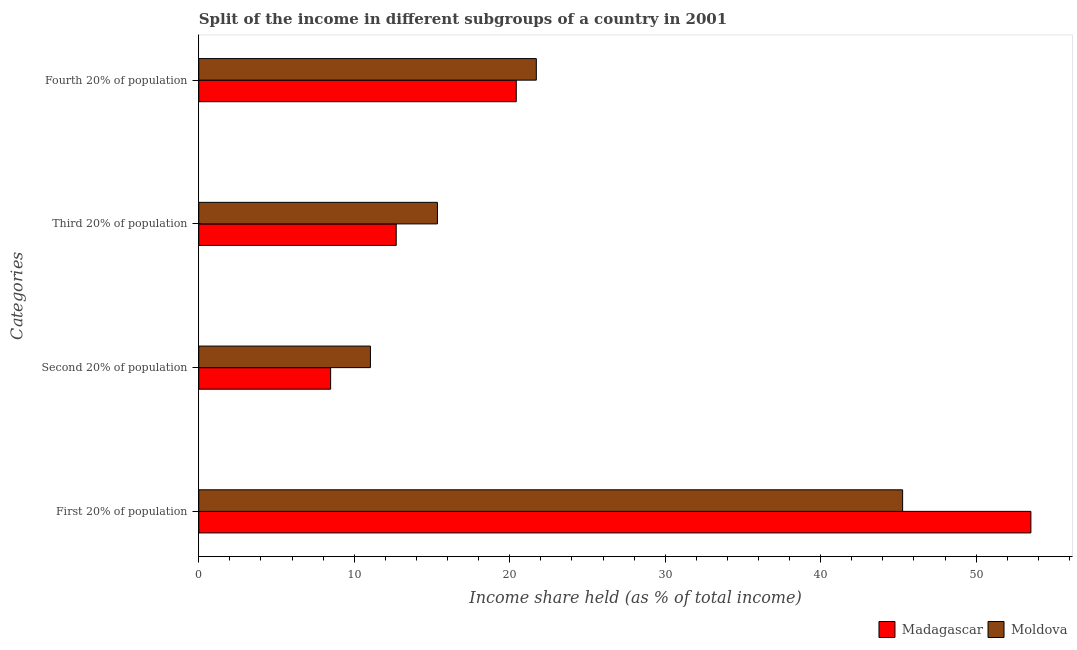How many different coloured bars are there?
Make the answer very short. 2. How many groups of bars are there?
Keep it short and to the point. 4. Are the number of bars per tick equal to the number of legend labels?
Offer a very short reply. Yes. What is the label of the 1st group of bars from the top?
Provide a short and direct response. Fourth 20% of population. What is the share of the income held by second 20% of the population in Moldova?
Make the answer very short. 11.04. Across all countries, what is the maximum share of the income held by first 20% of the population?
Give a very brief answer. 53.52. Across all countries, what is the minimum share of the income held by fourth 20% of the population?
Ensure brevity in your answer.  20.42. In which country was the share of the income held by first 20% of the population maximum?
Make the answer very short. Madagascar. In which country was the share of the income held by first 20% of the population minimum?
Your answer should be very brief. Moldova. What is the total share of the income held by second 20% of the population in the graph?
Offer a terse response. 19.52. What is the difference between the share of the income held by first 20% of the population in Moldova and that in Madagascar?
Provide a succinct answer. -8.25. What is the difference between the share of the income held by first 20% of the population in Moldova and the share of the income held by fourth 20% of the population in Madagascar?
Provide a succinct answer. 24.85. What is the average share of the income held by second 20% of the population per country?
Provide a short and direct response. 9.76. What is the difference between the share of the income held by first 20% of the population and share of the income held by fourth 20% of the population in Madagascar?
Provide a short and direct response. 33.1. In how many countries, is the share of the income held by third 20% of the population greater than 16 %?
Make the answer very short. 0. What is the ratio of the share of the income held by first 20% of the population in Madagascar to that in Moldova?
Keep it short and to the point. 1.18. Is the difference between the share of the income held by fourth 20% of the population in Moldova and Madagascar greater than the difference between the share of the income held by second 20% of the population in Moldova and Madagascar?
Give a very brief answer. No. What is the difference between the highest and the second highest share of the income held by fourth 20% of the population?
Keep it short and to the point. 1.29. What is the difference between the highest and the lowest share of the income held by first 20% of the population?
Make the answer very short. 8.25. In how many countries, is the share of the income held by fourth 20% of the population greater than the average share of the income held by fourth 20% of the population taken over all countries?
Give a very brief answer. 1. Is the sum of the share of the income held by first 20% of the population in Moldova and Madagascar greater than the maximum share of the income held by third 20% of the population across all countries?
Make the answer very short. Yes. What does the 1st bar from the top in First 20% of population represents?
Your answer should be very brief. Moldova. What does the 1st bar from the bottom in Fourth 20% of population represents?
Give a very brief answer. Madagascar. Is it the case that in every country, the sum of the share of the income held by first 20% of the population and share of the income held by second 20% of the population is greater than the share of the income held by third 20% of the population?
Your answer should be very brief. Yes. How many bars are there?
Your answer should be very brief. 8. Are all the bars in the graph horizontal?
Make the answer very short. Yes. How many countries are there in the graph?
Your answer should be compact. 2. Are the values on the major ticks of X-axis written in scientific E-notation?
Make the answer very short. No. Where does the legend appear in the graph?
Your response must be concise. Bottom right. How are the legend labels stacked?
Offer a terse response. Horizontal. What is the title of the graph?
Your response must be concise. Split of the income in different subgroups of a country in 2001. What is the label or title of the X-axis?
Your answer should be compact. Income share held (as % of total income). What is the label or title of the Y-axis?
Ensure brevity in your answer.  Categories. What is the Income share held (as % of total income) of Madagascar in First 20% of population?
Provide a short and direct response. 53.52. What is the Income share held (as % of total income) in Moldova in First 20% of population?
Keep it short and to the point. 45.27. What is the Income share held (as % of total income) in Madagascar in Second 20% of population?
Offer a very short reply. 8.48. What is the Income share held (as % of total income) in Moldova in Second 20% of population?
Offer a terse response. 11.04. What is the Income share held (as % of total income) of Moldova in Third 20% of population?
Your answer should be compact. 15.35. What is the Income share held (as % of total income) in Madagascar in Fourth 20% of population?
Your answer should be compact. 20.42. What is the Income share held (as % of total income) in Moldova in Fourth 20% of population?
Your answer should be very brief. 21.71. Across all Categories, what is the maximum Income share held (as % of total income) of Madagascar?
Keep it short and to the point. 53.52. Across all Categories, what is the maximum Income share held (as % of total income) of Moldova?
Your response must be concise. 45.27. Across all Categories, what is the minimum Income share held (as % of total income) in Madagascar?
Make the answer very short. 8.48. Across all Categories, what is the minimum Income share held (as % of total income) of Moldova?
Your answer should be compact. 11.04. What is the total Income share held (as % of total income) of Madagascar in the graph?
Your answer should be very brief. 95.12. What is the total Income share held (as % of total income) in Moldova in the graph?
Your response must be concise. 93.37. What is the difference between the Income share held (as % of total income) of Madagascar in First 20% of population and that in Second 20% of population?
Provide a succinct answer. 45.04. What is the difference between the Income share held (as % of total income) of Moldova in First 20% of population and that in Second 20% of population?
Ensure brevity in your answer.  34.23. What is the difference between the Income share held (as % of total income) in Madagascar in First 20% of population and that in Third 20% of population?
Your answer should be compact. 40.82. What is the difference between the Income share held (as % of total income) in Moldova in First 20% of population and that in Third 20% of population?
Make the answer very short. 29.92. What is the difference between the Income share held (as % of total income) in Madagascar in First 20% of population and that in Fourth 20% of population?
Provide a succinct answer. 33.1. What is the difference between the Income share held (as % of total income) in Moldova in First 20% of population and that in Fourth 20% of population?
Make the answer very short. 23.56. What is the difference between the Income share held (as % of total income) in Madagascar in Second 20% of population and that in Third 20% of population?
Your answer should be very brief. -4.22. What is the difference between the Income share held (as % of total income) in Moldova in Second 20% of population and that in Third 20% of population?
Offer a terse response. -4.31. What is the difference between the Income share held (as % of total income) in Madagascar in Second 20% of population and that in Fourth 20% of population?
Make the answer very short. -11.94. What is the difference between the Income share held (as % of total income) in Moldova in Second 20% of population and that in Fourth 20% of population?
Offer a very short reply. -10.67. What is the difference between the Income share held (as % of total income) in Madagascar in Third 20% of population and that in Fourth 20% of population?
Offer a terse response. -7.72. What is the difference between the Income share held (as % of total income) in Moldova in Third 20% of population and that in Fourth 20% of population?
Make the answer very short. -6.36. What is the difference between the Income share held (as % of total income) in Madagascar in First 20% of population and the Income share held (as % of total income) in Moldova in Second 20% of population?
Offer a terse response. 42.48. What is the difference between the Income share held (as % of total income) in Madagascar in First 20% of population and the Income share held (as % of total income) in Moldova in Third 20% of population?
Your answer should be very brief. 38.17. What is the difference between the Income share held (as % of total income) in Madagascar in First 20% of population and the Income share held (as % of total income) in Moldova in Fourth 20% of population?
Ensure brevity in your answer.  31.81. What is the difference between the Income share held (as % of total income) of Madagascar in Second 20% of population and the Income share held (as % of total income) of Moldova in Third 20% of population?
Give a very brief answer. -6.87. What is the difference between the Income share held (as % of total income) of Madagascar in Second 20% of population and the Income share held (as % of total income) of Moldova in Fourth 20% of population?
Give a very brief answer. -13.23. What is the difference between the Income share held (as % of total income) in Madagascar in Third 20% of population and the Income share held (as % of total income) in Moldova in Fourth 20% of population?
Offer a terse response. -9.01. What is the average Income share held (as % of total income) in Madagascar per Categories?
Your answer should be very brief. 23.78. What is the average Income share held (as % of total income) of Moldova per Categories?
Keep it short and to the point. 23.34. What is the difference between the Income share held (as % of total income) of Madagascar and Income share held (as % of total income) of Moldova in First 20% of population?
Ensure brevity in your answer.  8.25. What is the difference between the Income share held (as % of total income) in Madagascar and Income share held (as % of total income) in Moldova in Second 20% of population?
Provide a succinct answer. -2.56. What is the difference between the Income share held (as % of total income) in Madagascar and Income share held (as % of total income) in Moldova in Third 20% of population?
Provide a short and direct response. -2.65. What is the difference between the Income share held (as % of total income) of Madagascar and Income share held (as % of total income) of Moldova in Fourth 20% of population?
Offer a terse response. -1.29. What is the ratio of the Income share held (as % of total income) of Madagascar in First 20% of population to that in Second 20% of population?
Give a very brief answer. 6.31. What is the ratio of the Income share held (as % of total income) of Moldova in First 20% of population to that in Second 20% of population?
Your response must be concise. 4.1. What is the ratio of the Income share held (as % of total income) of Madagascar in First 20% of population to that in Third 20% of population?
Your answer should be compact. 4.21. What is the ratio of the Income share held (as % of total income) of Moldova in First 20% of population to that in Third 20% of population?
Your answer should be compact. 2.95. What is the ratio of the Income share held (as % of total income) of Madagascar in First 20% of population to that in Fourth 20% of population?
Keep it short and to the point. 2.62. What is the ratio of the Income share held (as % of total income) of Moldova in First 20% of population to that in Fourth 20% of population?
Provide a succinct answer. 2.09. What is the ratio of the Income share held (as % of total income) in Madagascar in Second 20% of population to that in Third 20% of population?
Your answer should be very brief. 0.67. What is the ratio of the Income share held (as % of total income) of Moldova in Second 20% of population to that in Third 20% of population?
Your response must be concise. 0.72. What is the ratio of the Income share held (as % of total income) of Madagascar in Second 20% of population to that in Fourth 20% of population?
Give a very brief answer. 0.42. What is the ratio of the Income share held (as % of total income) in Moldova in Second 20% of population to that in Fourth 20% of population?
Provide a short and direct response. 0.51. What is the ratio of the Income share held (as % of total income) in Madagascar in Third 20% of population to that in Fourth 20% of population?
Keep it short and to the point. 0.62. What is the ratio of the Income share held (as % of total income) of Moldova in Third 20% of population to that in Fourth 20% of population?
Ensure brevity in your answer.  0.71. What is the difference between the highest and the second highest Income share held (as % of total income) in Madagascar?
Keep it short and to the point. 33.1. What is the difference between the highest and the second highest Income share held (as % of total income) in Moldova?
Provide a succinct answer. 23.56. What is the difference between the highest and the lowest Income share held (as % of total income) in Madagascar?
Your response must be concise. 45.04. What is the difference between the highest and the lowest Income share held (as % of total income) in Moldova?
Provide a succinct answer. 34.23. 